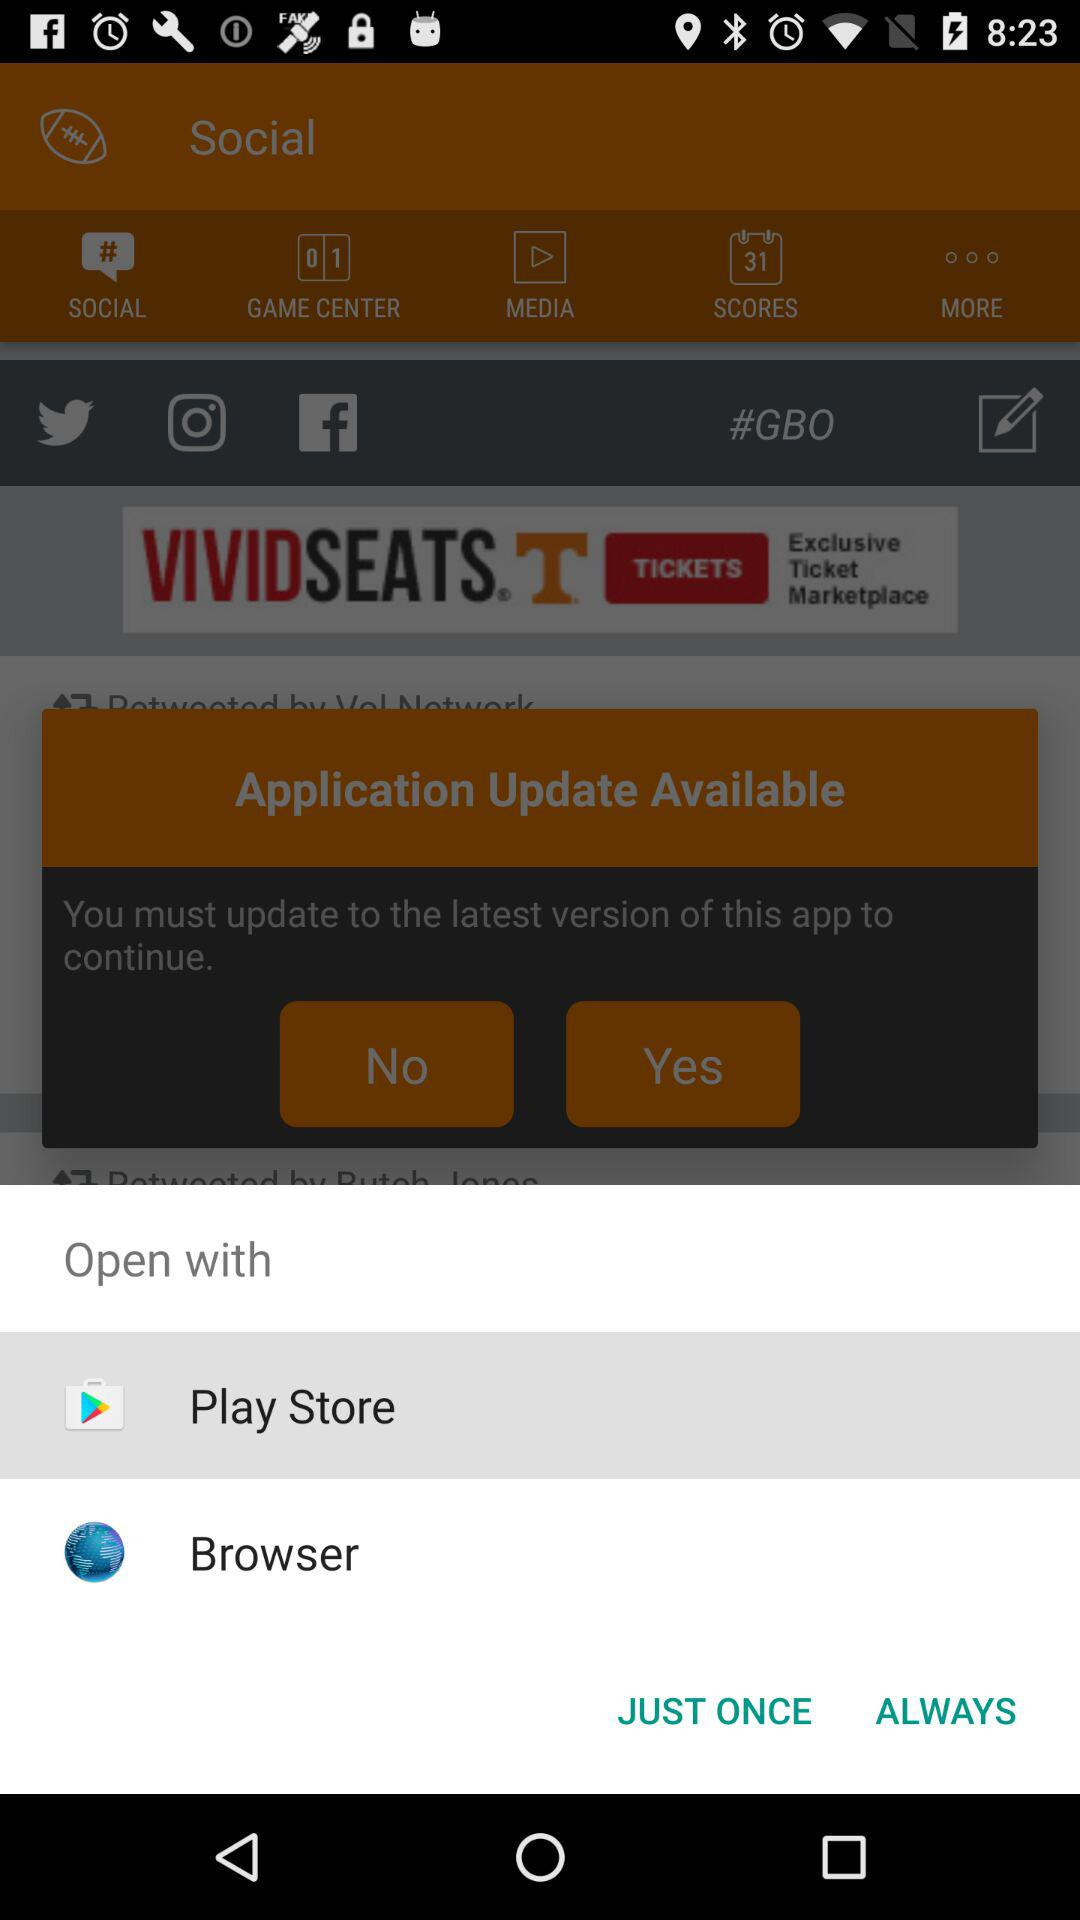What applications can be used to open the content? The applications that can be used to open the content are "Play Store" and "Browser". 